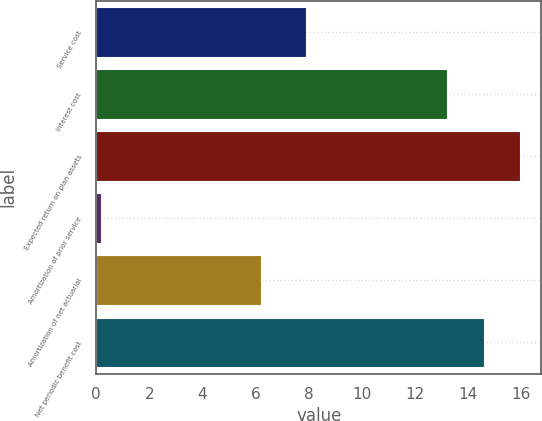<chart> <loc_0><loc_0><loc_500><loc_500><bar_chart><fcel>Service cost<fcel>Interest cost<fcel>Expected return on plan assets<fcel>Amortization of prior service<fcel>Amortization of net actuarial<fcel>Net periodic benefit cost<nl><fcel>7.9<fcel>13.2<fcel>15.96<fcel>0.2<fcel>6.2<fcel>14.58<nl></chart> 